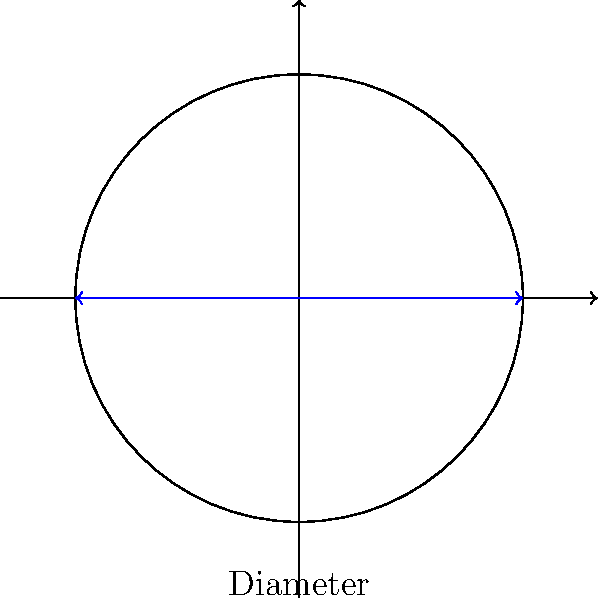Your adorable puppy needs a new water bowl. You've found a circular bowl with a diameter of 12 inches. What is the perimeter (circumference) of this bowl? To find the perimeter (circumference) of a circular dog bowl, we need to use the formula for the circumference of a circle:

$$C = \pi d$$

Where:
$C$ is the circumference
$\pi$ is approximately 3.14159
$d$ is the diameter

Given:
Diameter $(d) = 12$ inches

Step 1: Substitute the given diameter into the formula:
$$C = \pi \times 12$$

Step 2: Multiply:
$$C = 3.14159 \times 12 = 37.69908$$

Step 3: Round to two decimal places:
$$C \approx 37.70\text{ inches}$$

Therefore, the perimeter (circumference) of the circular dog bowl is approximately 37.70 inches.
Answer: $37.70\text{ inches}$ 